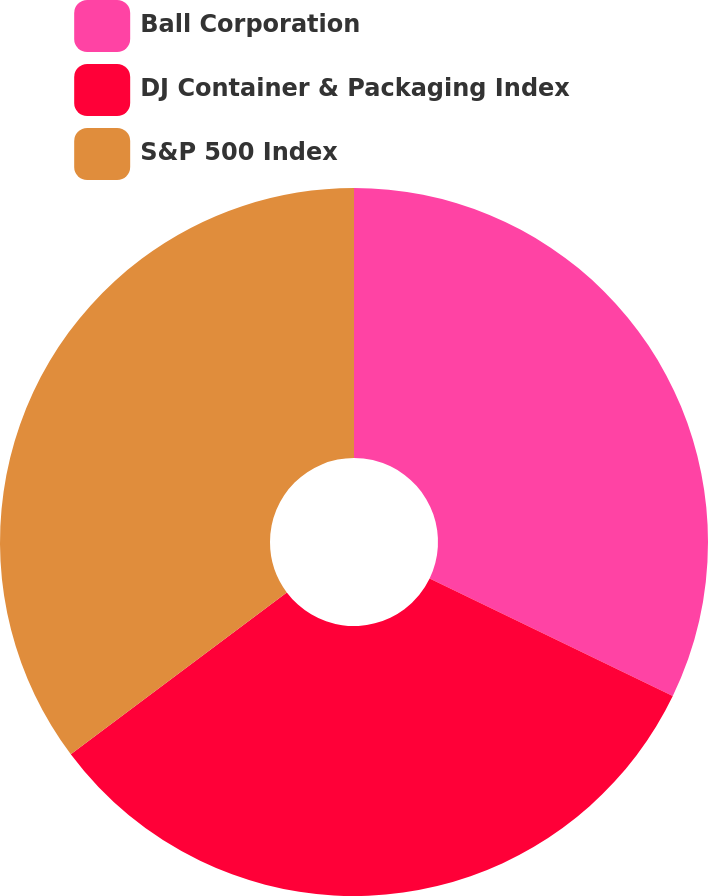<chart> <loc_0><loc_0><loc_500><loc_500><pie_chart><fcel>Ball Corporation<fcel>DJ Container & Packaging Index<fcel>S&P 500 Index<nl><fcel>32.16%<fcel>32.6%<fcel>35.24%<nl></chart> 